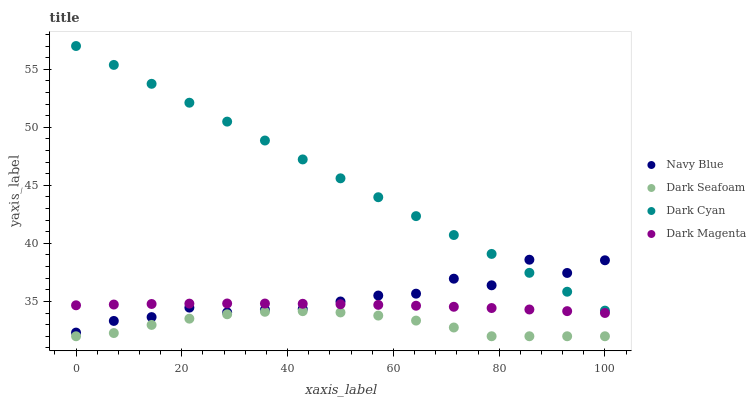Does Dark Seafoam have the minimum area under the curve?
Answer yes or no. Yes. Does Dark Cyan have the maximum area under the curve?
Answer yes or no. Yes. Does Navy Blue have the minimum area under the curve?
Answer yes or no. No. Does Navy Blue have the maximum area under the curve?
Answer yes or no. No. Is Dark Cyan the smoothest?
Answer yes or no. Yes. Is Navy Blue the roughest?
Answer yes or no. Yes. Is Dark Seafoam the smoothest?
Answer yes or no. No. Is Dark Seafoam the roughest?
Answer yes or no. No. Does Dark Seafoam have the lowest value?
Answer yes or no. Yes. Does Navy Blue have the lowest value?
Answer yes or no. No. Does Dark Cyan have the highest value?
Answer yes or no. Yes. Does Navy Blue have the highest value?
Answer yes or no. No. Is Dark Magenta less than Dark Cyan?
Answer yes or no. Yes. Is Dark Magenta greater than Dark Seafoam?
Answer yes or no. Yes. Does Dark Cyan intersect Navy Blue?
Answer yes or no. Yes. Is Dark Cyan less than Navy Blue?
Answer yes or no. No. Is Dark Cyan greater than Navy Blue?
Answer yes or no. No. Does Dark Magenta intersect Dark Cyan?
Answer yes or no. No. 